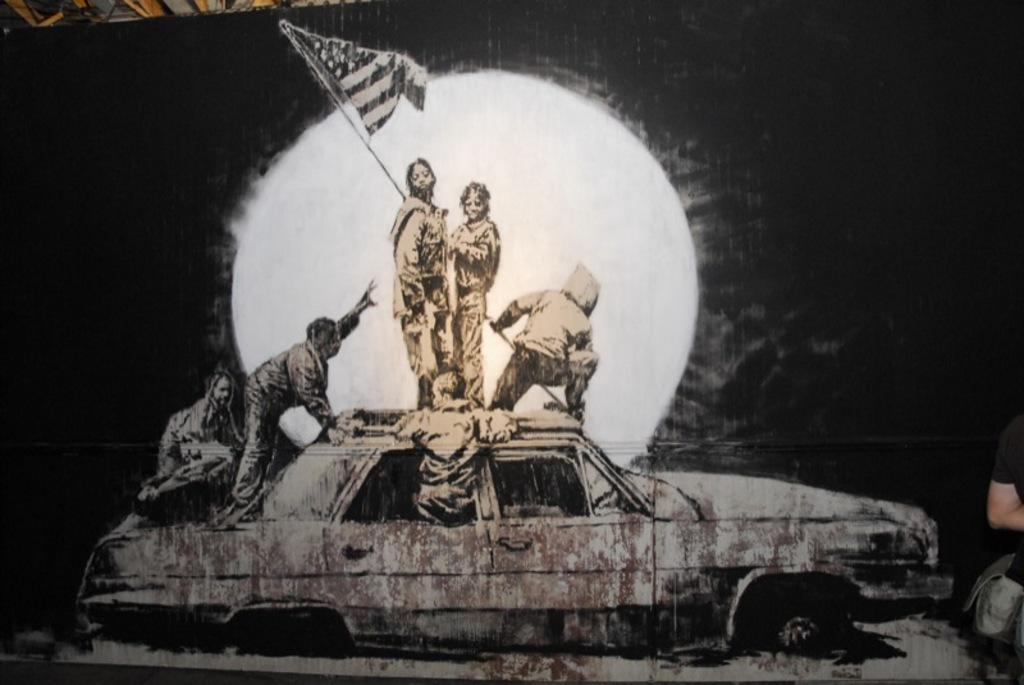What is happening in the image? There are people on a car in the image. What is the person holding in the image? One person is holding a flag. How is the image presented in terms of color? The background of the image is in black and white. What type of drug can be seen in the pocket of the person on the car? There is no drug present in the image, nor is there any indication of a pocket on the person. 